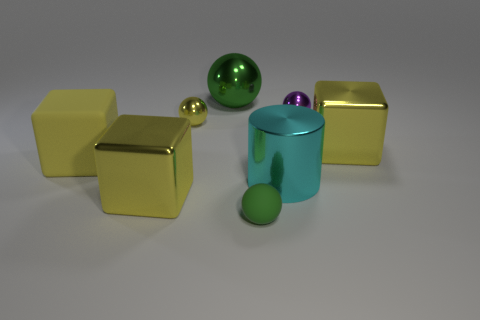Imagine these items are part of a puzzle, what could be the objective based on their shapes and colors? If these items are part of a puzzle, the objective might be to arrange them according to specific color or size sequences, or perhaps to fit them together based on their geometric shapes to complete a larger design or structure. 